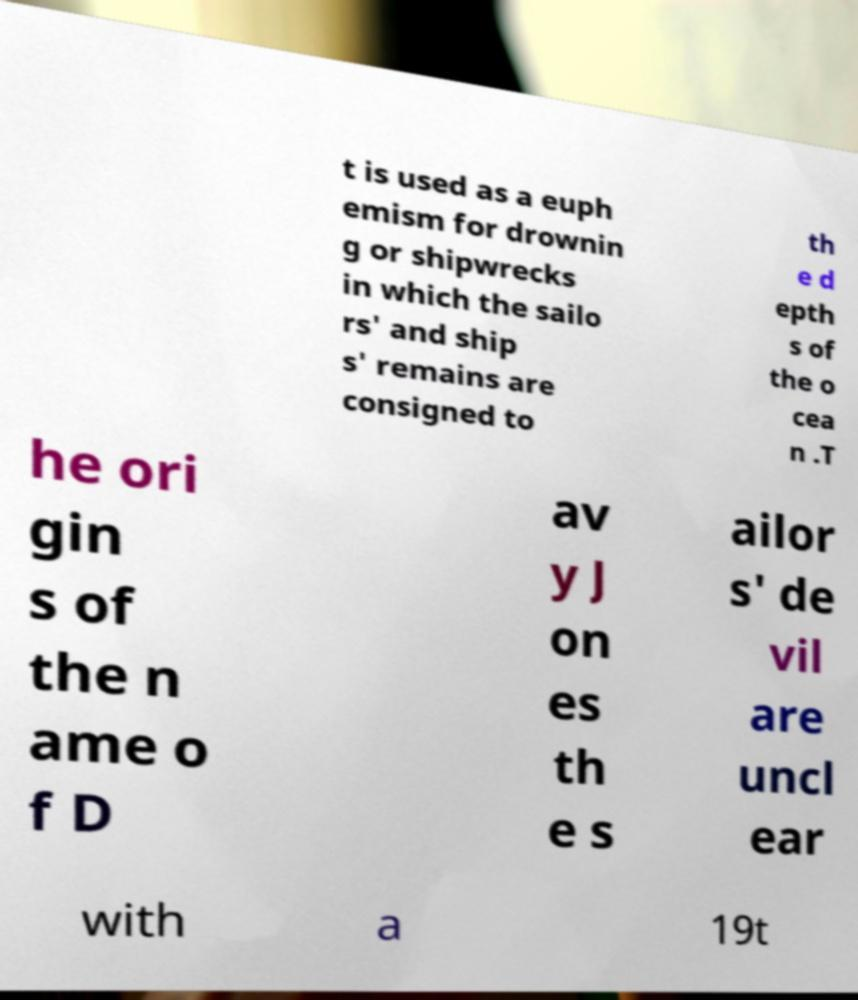Can you accurately transcribe the text from the provided image for me? t is used as a euph emism for drownin g or shipwrecks in which the sailo rs' and ship s' remains are consigned to th e d epth s of the o cea n .T he ori gin s of the n ame o f D av y J on es th e s ailor s' de vil are uncl ear with a 19t 